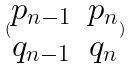<formula> <loc_0><loc_0><loc_500><loc_500>( \begin{matrix} p _ { n - 1 } & p _ { n } \\ q _ { n - 1 } & q _ { n } \end{matrix} )</formula> 